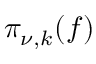<formula> <loc_0><loc_0><loc_500><loc_500>\pi _ { \nu , k } ( f )</formula> 